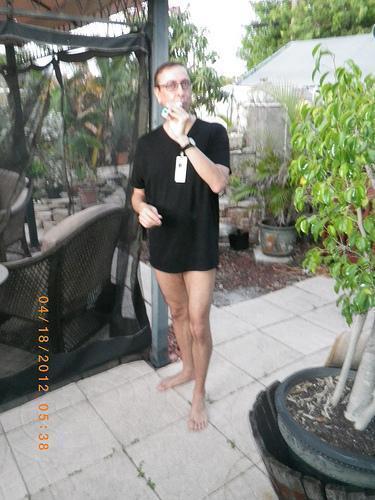How many people are shown?
Give a very brief answer. 1. 